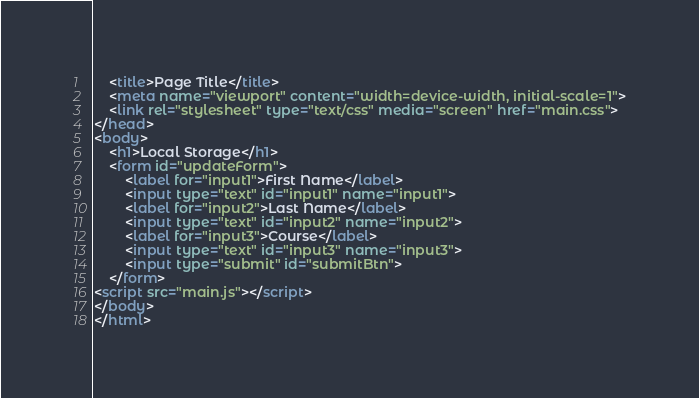<code> <loc_0><loc_0><loc_500><loc_500><_HTML_>    <title>Page Title</title>
    <meta name="viewport" content="width=device-width, initial-scale=1">
    <link rel="stylesheet" type="text/css" media="screen" href="main.css">
</head>
<body>
    <h1>Local Storage</h1>
    <form id="updateForm">
        <label for="input1">First Name</label>
        <input type="text" id="input1" name="input1">
        <label for="input2">Last Name</label>
        <input type="text" id="input2" name="input2">
        <label for="input3">Course</label>
        <input type="text" id="input3" name="input3">
        <input type="submit" id="submitBtn">
    </form>   
<script src="main.js"></script>
</body>
</html></code> 